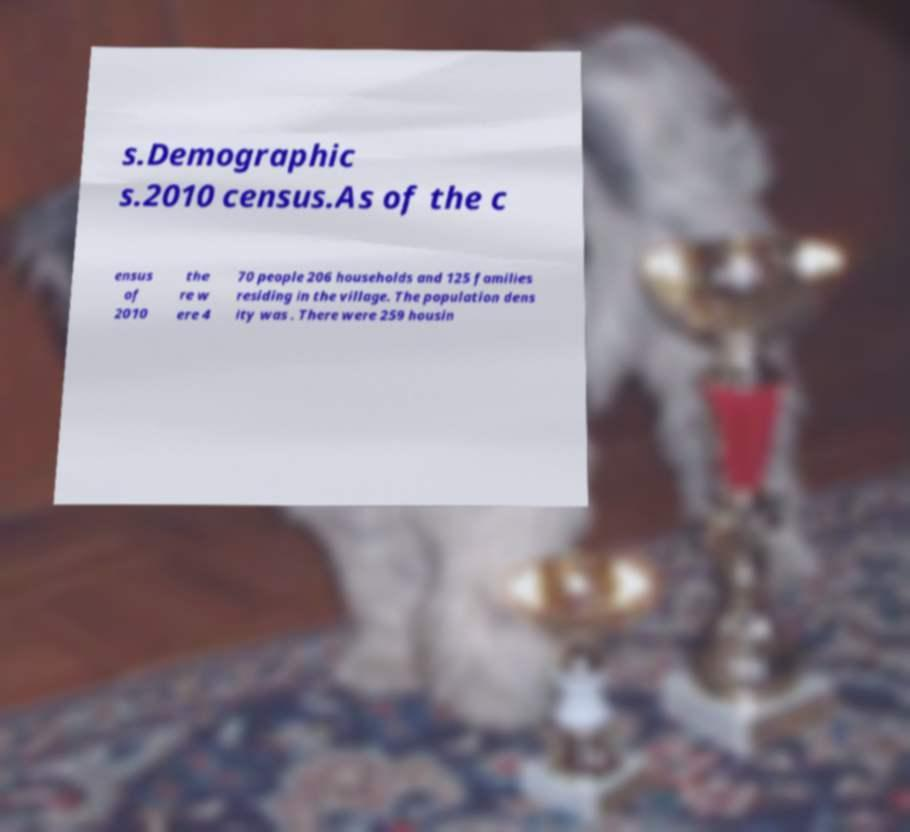What messages or text are displayed in this image? I need them in a readable, typed format. s.Demographic s.2010 census.As of the c ensus of 2010 the re w ere 4 70 people 206 households and 125 families residing in the village. The population dens ity was . There were 259 housin 